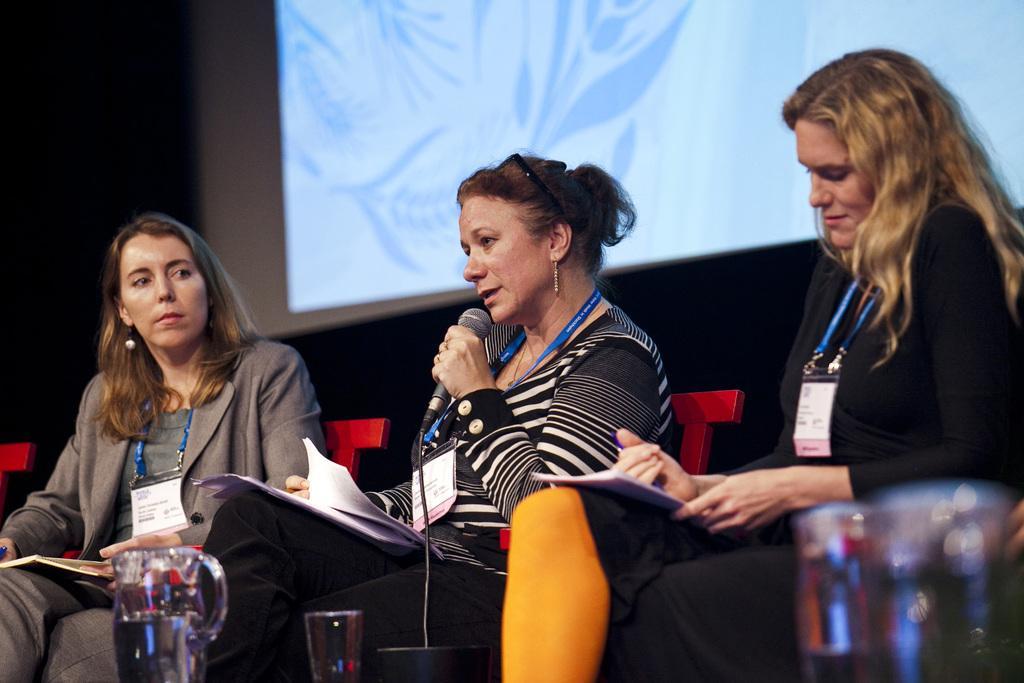Describe this image in one or two sentences. In this image I can see there are two women sitting on the chair and in the middle woman she holding a mike and paper, in front of them I can see a jar and glass ,at the top I can see screen and three women wearing a blue color id-card. 